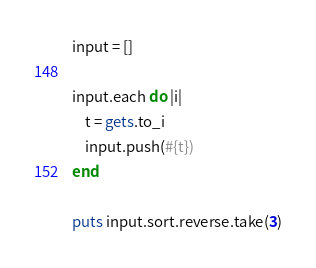<code> <loc_0><loc_0><loc_500><loc_500><_Ruby_>input = []

input.each do |i| 
    t = gets.to_i
    input.push(#{t})
end

puts input.sort.reverse.take(3)

</code> 